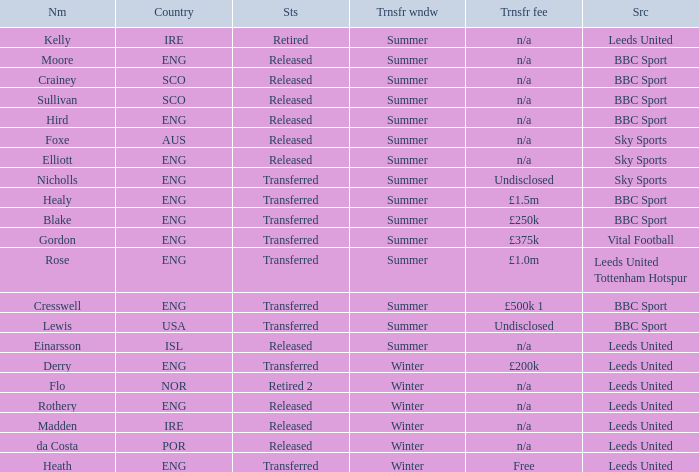What was the transfer fee for the summer transfer involving the SCO named Crainey? N/a. 